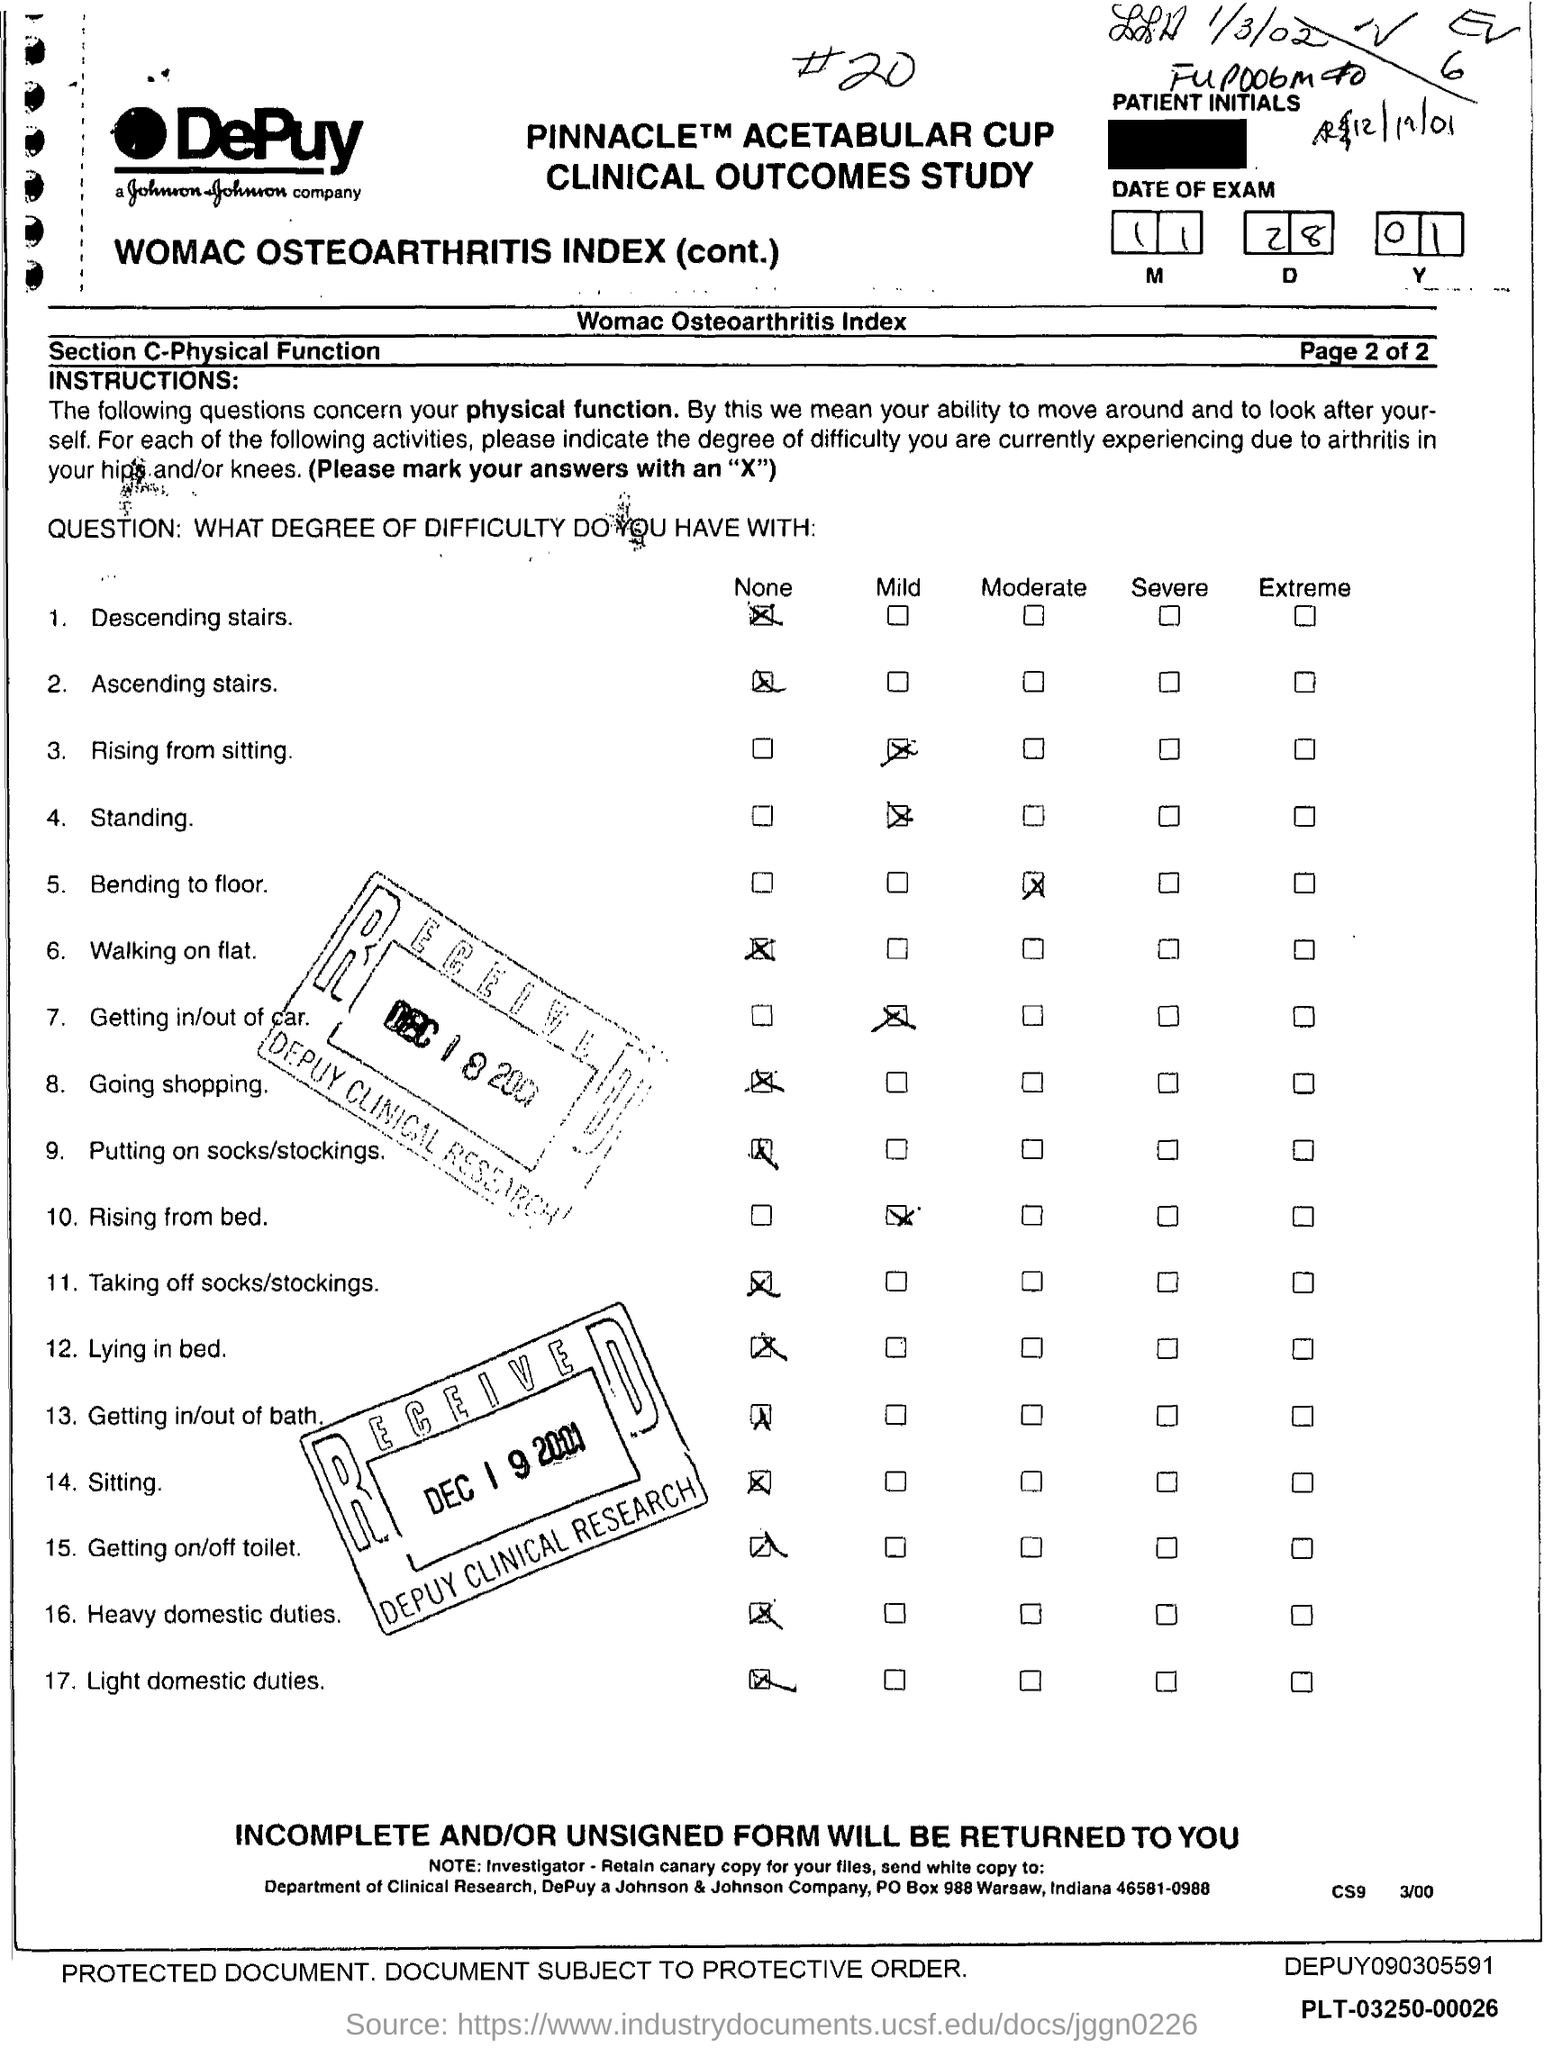What is the date of exam mentioned in the form?
Keep it short and to the point. 11.28.01. 